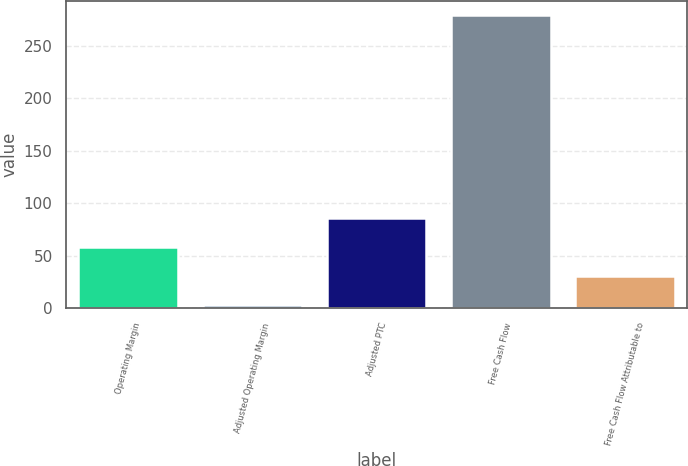Convert chart. <chart><loc_0><loc_0><loc_500><loc_500><bar_chart><fcel>Operating Margin<fcel>Adjusted Operating Margin<fcel>Adjusted PTC<fcel>Free Cash Flow<fcel>Free Cash Flow Attributable to<nl><fcel>58.2<fcel>3<fcel>85.8<fcel>279<fcel>30.6<nl></chart> 